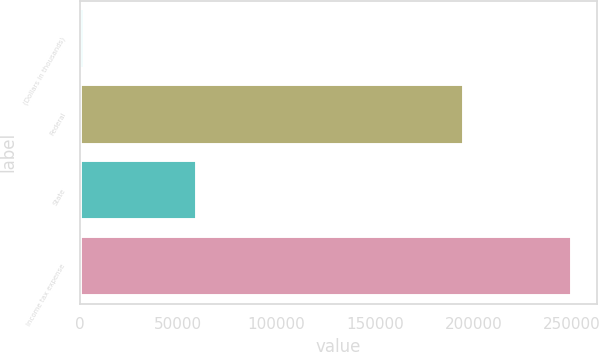Convert chart to OTSL. <chart><loc_0><loc_0><loc_500><loc_500><bar_chart><fcel>(Dollars in thousands)<fcel>Federal<fcel>State<fcel>Income tax expense<nl><fcel>2016<fcel>195249<fcel>59319<fcel>250333<nl></chart> 